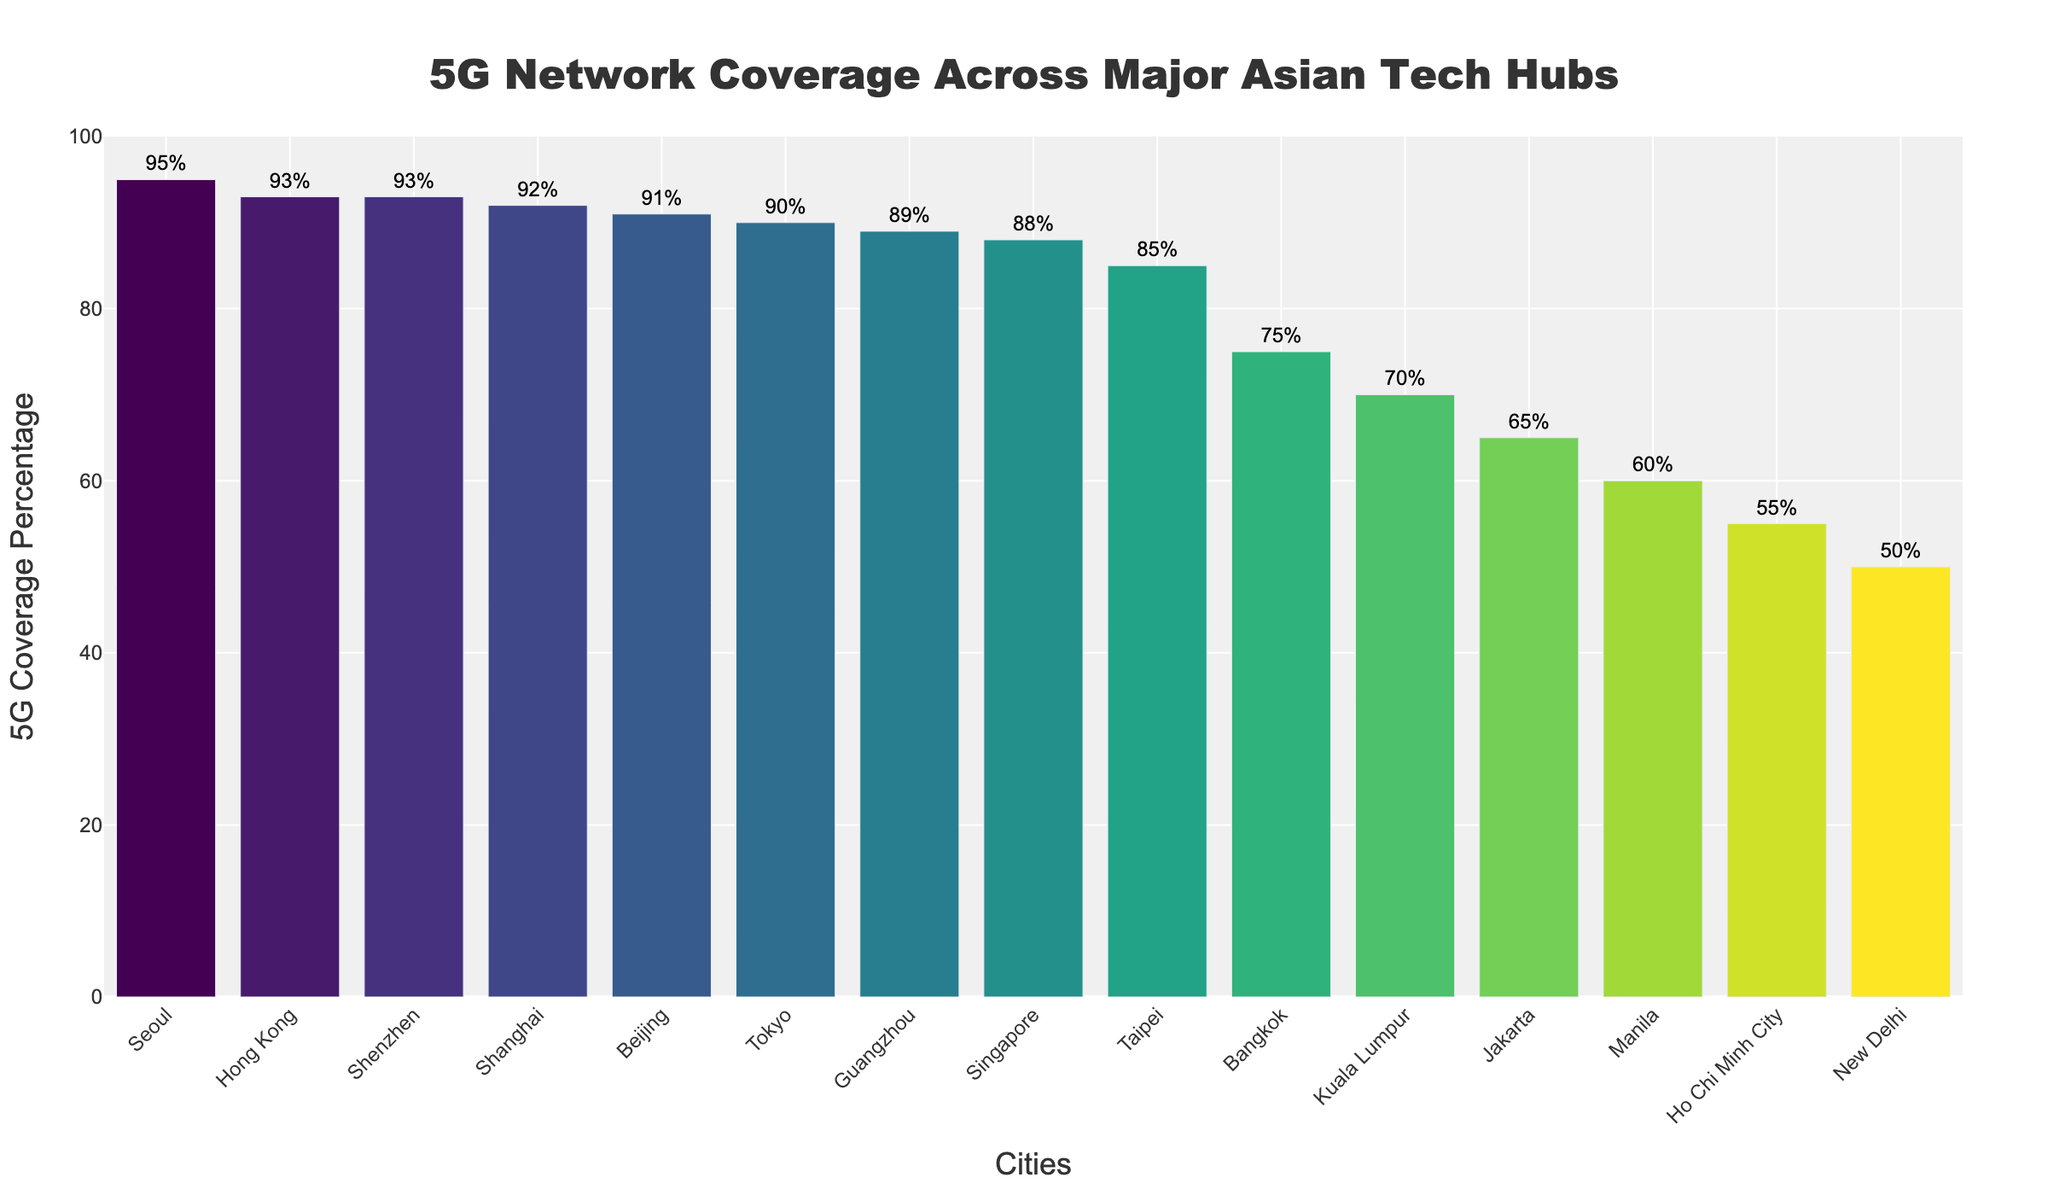What's the city with the highest 5G coverage percentage? The city with the highest coverage is the one with the tallest bar. Seoul has the highest bar at 95%.
Answer: Seoul Which city has the lowest 5G coverage among the listed tech hubs? The city with the lowest 5G coverage is the one with the shortest bar. Ho Chi Minh City has the shortest bar at 55%.
Answer: Ho Chi Minh City How much higher is Seoul's 5G coverage compared to New Delhi? Find the 5G coverage of Seoul and New Delhi, then subtract New Delhi's percentage from Seoul's. Seoul has 95% and New Delhi has 50%, so 95% - 50% = 45%.
Answer: 45% What is the average 5G coverage percentage across all listed cities? Sum all 5G percentages and divide by the number of cities. (93 + 95 + 90 + 88 + 85 + 92 + 91 + 93 + 89 + 75 + 70 + 65 + 60 + 55 + 50) / 15 = 1271 / 15 ≈ 84.73
Answer: 84.73 Which city has 5G coverage closest to 90%? Look for the city with a bar height closest to the 90% mark. Tokyo, with 90%, and Shanghai, with 92%, are closest, but Tokyo matches exactly.
Answer: Tokyo What is the difference in 5G coverage between Hong Kong and Taipei? Subtract the coverage percentage of Taipei from that of Hong Kong. Hong Kong has 93% and Taipei has 85%, so 93% - 85% = 8%.
Answer: 8% What is the total 5G coverage percentage for the three cities with the highest coverage? Identify the cities with the highest 5G coverage, which are Seoul (95%), Hong Kong (93%), and Shenzhen (93%), and then sum these percentages. 95 + 93 + 93 = 281
Answer: 281 Is the 5G coverage of Singapore greater than that of Beijing? Compare the bar heights of Singapore and Beijing. Singapore has 88%, and Beijing has 91%, so Singapore's coverage is lower.
Answer: No 